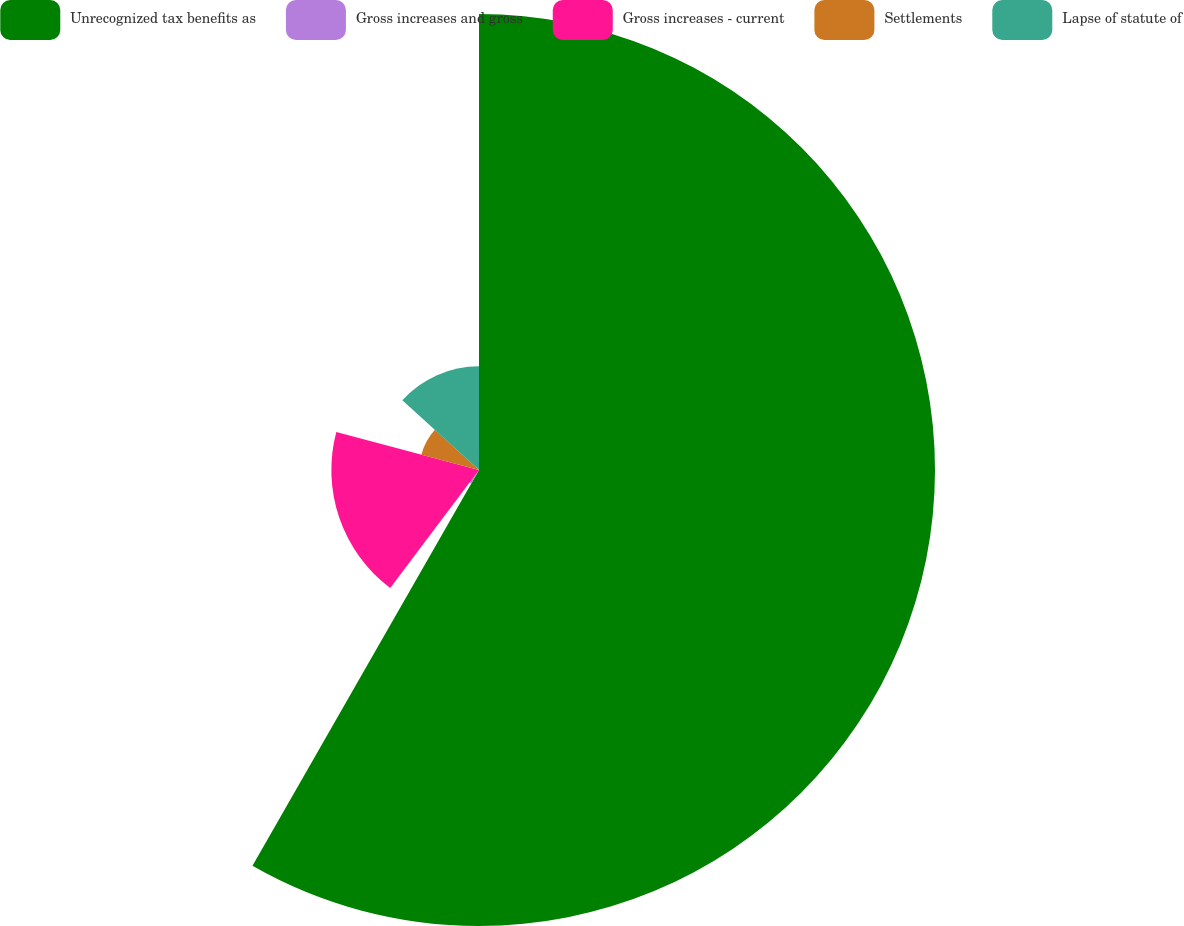Convert chart to OTSL. <chart><loc_0><loc_0><loc_500><loc_500><pie_chart><fcel>Unrecognized tax benefits as<fcel>Gross increases and gross<fcel>Gross increases - current<fcel>Settlements<fcel>Lapse of statute of<nl><fcel>58.28%<fcel>1.99%<fcel>18.87%<fcel>7.62%<fcel>13.25%<nl></chart> 